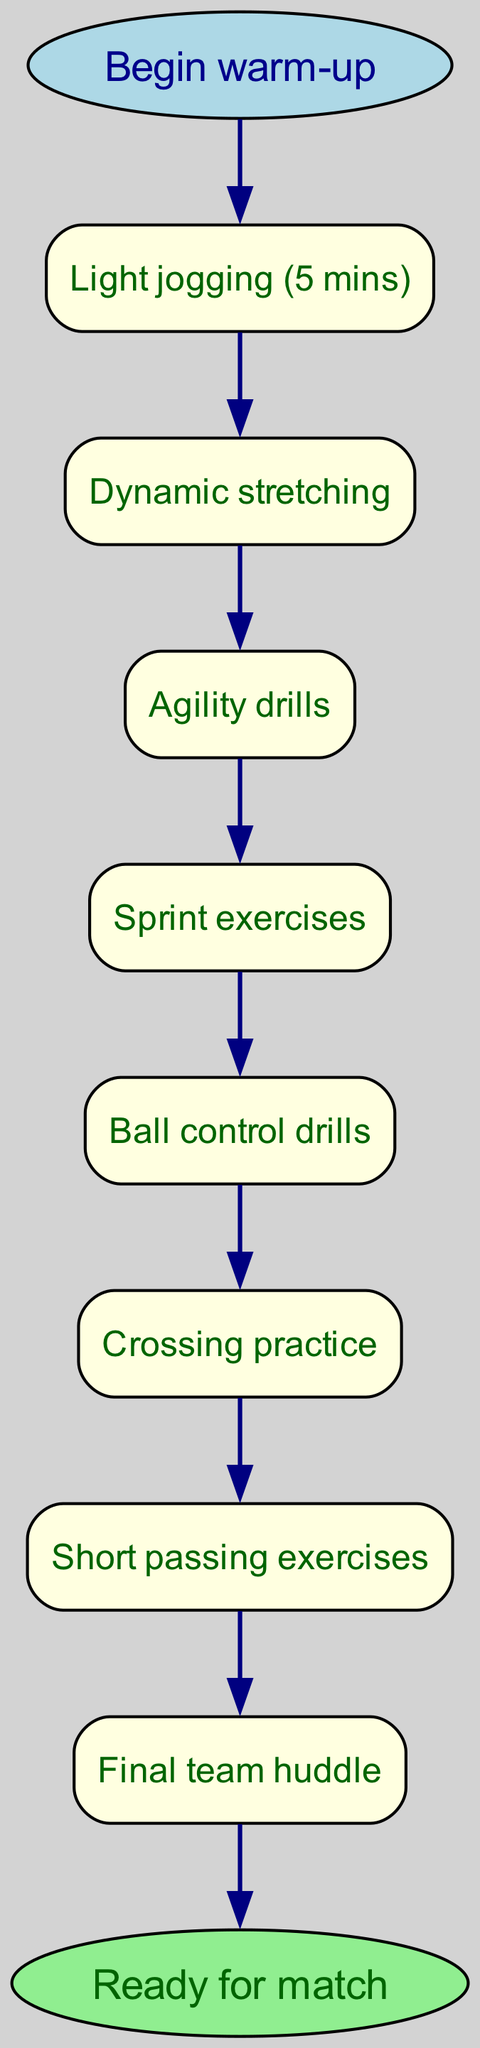What is the first activity in the warm-up routine? The first node in the diagram lists "Light jogging (5 mins)" as the initial activity following the start node.
Answer: Light jogging (5 mins) How many activities are there in total before the final team huddle? By counting the nodes from "Light jogging (5 mins)" to "Short passing exercises," there are 7 activities before reaching the final team huddle.
Answer: 7 What follows agility drills in the routine? The edge from the node representing "Agility drills" connects directly to the next node, which is "Sprint exercises."
Answer: Sprint exercises What is the last step in the warm-up routine? The final node directly before the end node is labeled as "Final team huddle," which indicates the last step before the warm-up is complete.
Answer: Final team huddle Which activity occurs immediately before ball control drills? Examining the nodes, "Sprint exercises" is the activity that comes right before "Ball control drills."
Answer: Sprint exercises What is the relationship between dynamic stretching and agility drills? There is a direct link in the diagram from "Dynamic stretching" to "Agility drills," indicating that agility drills directly follow dynamic stretching in the routine.
Answer: Directly follows How many total nodes are there including start and end nodes? Counting all listed activities and including both the start and end nodes, there are a total of 9 nodes in the diagram.
Answer: 9 What type of diagram represents the warm-up routine? The structure of the diagram, which shows a sequence of steps leading from a starting point to an endpoint, is indicative of a flow chart.
Answer: Flow chart 